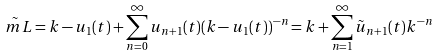Convert formula to latex. <formula><loc_0><loc_0><loc_500><loc_500>\tilde { \ m L } = k - u _ { 1 } ( t ) + \sum _ { n = 0 } ^ { \infty } u _ { n + 1 } ( t ) ( k - u _ { 1 } ( t ) ) ^ { - n } = k + \sum _ { n = 1 } ^ { \infty } \tilde { u } _ { n + 1 } ( t ) k ^ { - n }</formula> 